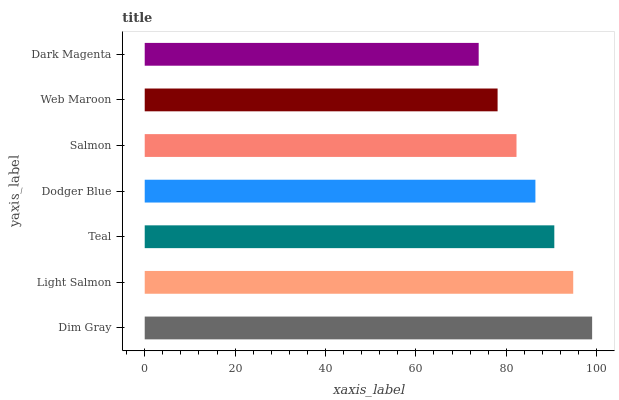Is Dark Magenta the minimum?
Answer yes or no. Yes. Is Dim Gray the maximum?
Answer yes or no. Yes. Is Light Salmon the minimum?
Answer yes or no. No. Is Light Salmon the maximum?
Answer yes or no. No. Is Dim Gray greater than Light Salmon?
Answer yes or no. Yes. Is Light Salmon less than Dim Gray?
Answer yes or no. Yes. Is Light Salmon greater than Dim Gray?
Answer yes or no. No. Is Dim Gray less than Light Salmon?
Answer yes or no. No. Is Dodger Blue the high median?
Answer yes or no. Yes. Is Dodger Blue the low median?
Answer yes or no. Yes. Is Web Maroon the high median?
Answer yes or no. No. Is Light Salmon the low median?
Answer yes or no. No. 